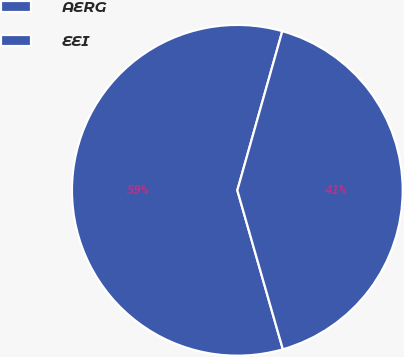Convert chart to OTSL. <chart><loc_0><loc_0><loc_500><loc_500><pie_chart><fcel>AERG<fcel>EEI<nl><fcel>58.82%<fcel>41.18%<nl></chart> 